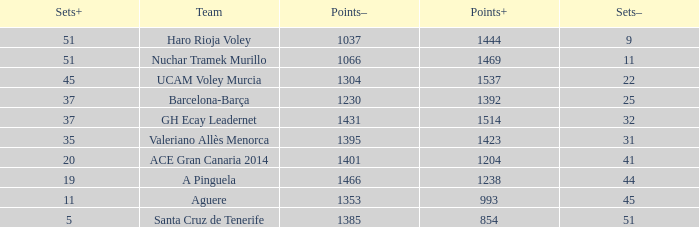What is the highest Sets+ number for Valeriano Allès Menorca when the Sets- number was larger than 31? None. 